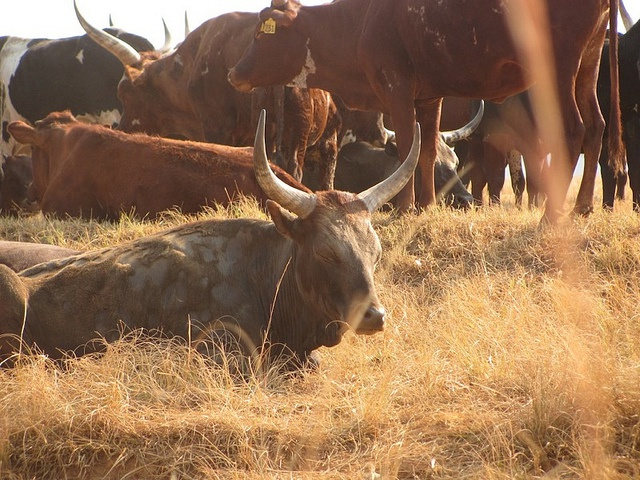Describe the objects in this image and their specific colors. I can see cow in white, maroon, and gray tones, cow in white, maroon, brown, and gray tones, cow in white, maroon, brown, and gray tones, cow in white, maroon, brown, and tan tones, and cow in white, black, and gray tones in this image. 